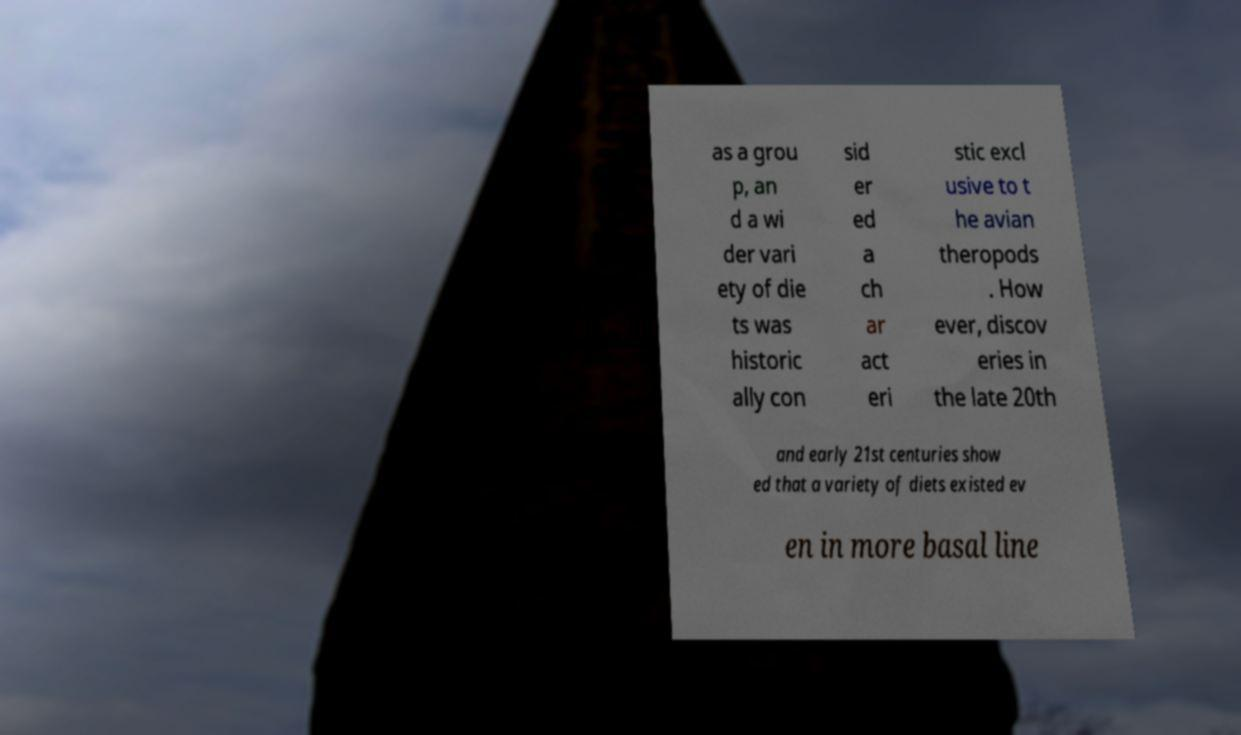What messages or text are displayed in this image? I need them in a readable, typed format. as a grou p, an d a wi der vari ety of die ts was historic ally con sid er ed a ch ar act eri stic excl usive to t he avian theropods . How ever, discov eries in the late 20th and early 21st centuries show ed that a variety of diets existed ev en in more basal line 